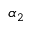<formula> <loc_0><loc_0><loc_500><loc_500>\alpha _ { 2 }</formula> 